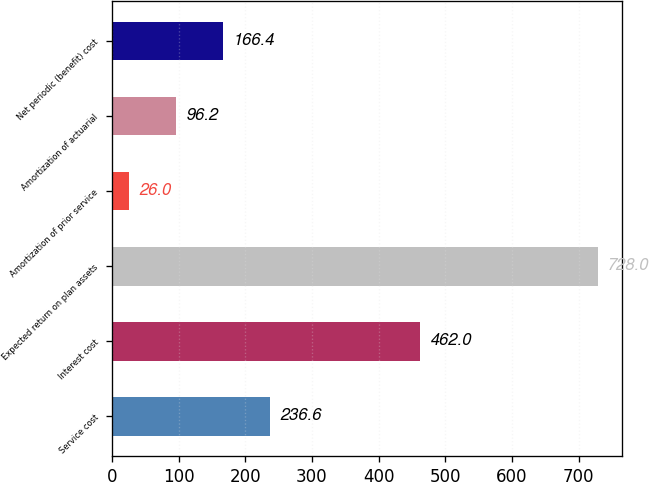<chart> <loc_0><loc_0><loc_500><loc_500><bar_chart><fcel>Service cost<fcel>Interest cost<fcel>Expected return on plan assets<fcel>Amortization of prior service<fcel>Amortization of actuarial<fcel>Net periodic (benefit) cost<nl><fcel>236.6<fcel>462<fcel>728<fcel>26<fcel>96.2<fcel>166.4<nl></chart> 